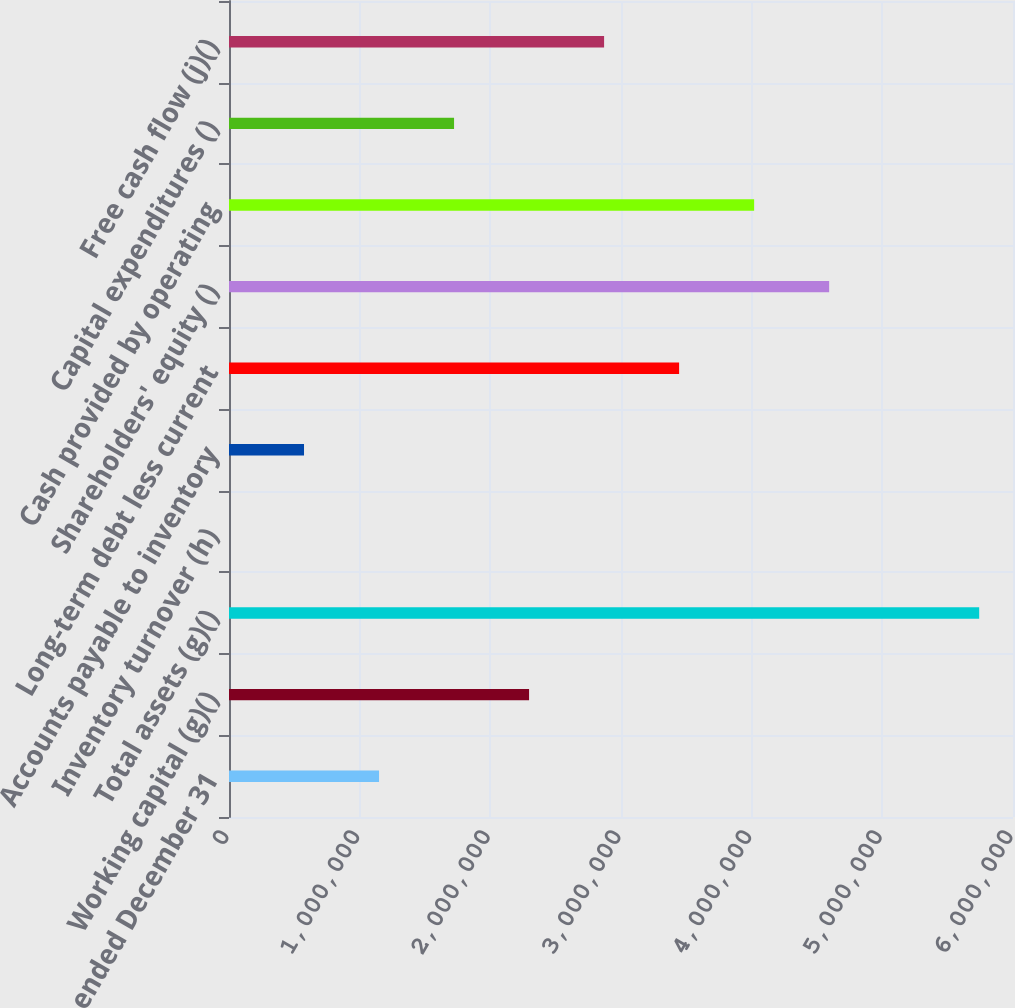<chart> <loc_0><loc_0><loc_500><loc_500><bar_chart><fcel>Years ended December 31<fcel>Working capital (g)()<fcel>Total assets (g)()<fcel>Inventory turnover (h)<fcel>Accounts payable to inventory<fcel>Long-term debt less current<fcel>Shareholders' equity ()<fcel>Cash provided by operating<fcel>Capital expenditures ()<fcel>Free cash flow (j)()<nl><fcel>1.14825e+06<fcel>2.2965e+06<fcel>5.74124e+06<fcel>1.4<fcel>574125<fcel>3.44475e+06<fcel>4.59299e+06<fcel>4.01887e+06<fcel>1.72237e+06<fcel>2.87062e+06<nl></chart> 